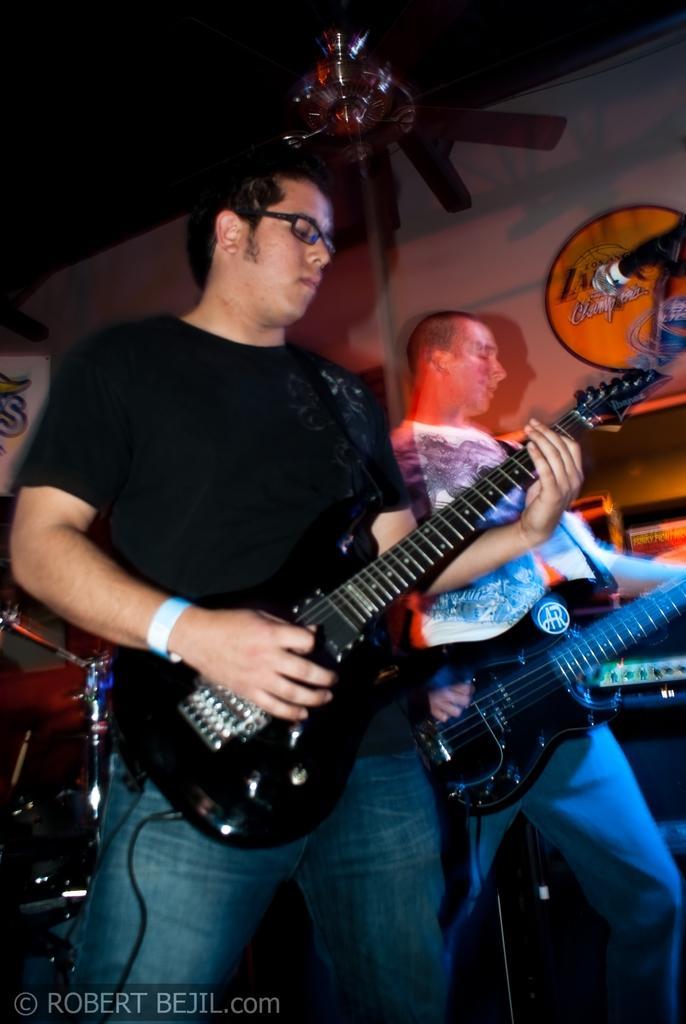Could you give a brief overview of what you see in this image? In this picture we can see two men standing and playing guitars. He wore wrist band and spectacles. This is a mike. 